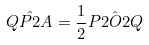<formula> <loc_0><loc_0><loc_500><loc_500>\hat { Q P 2 A } = \frac { 1 } { 2 } \hat { P 2 O 2 Q }</formula> 